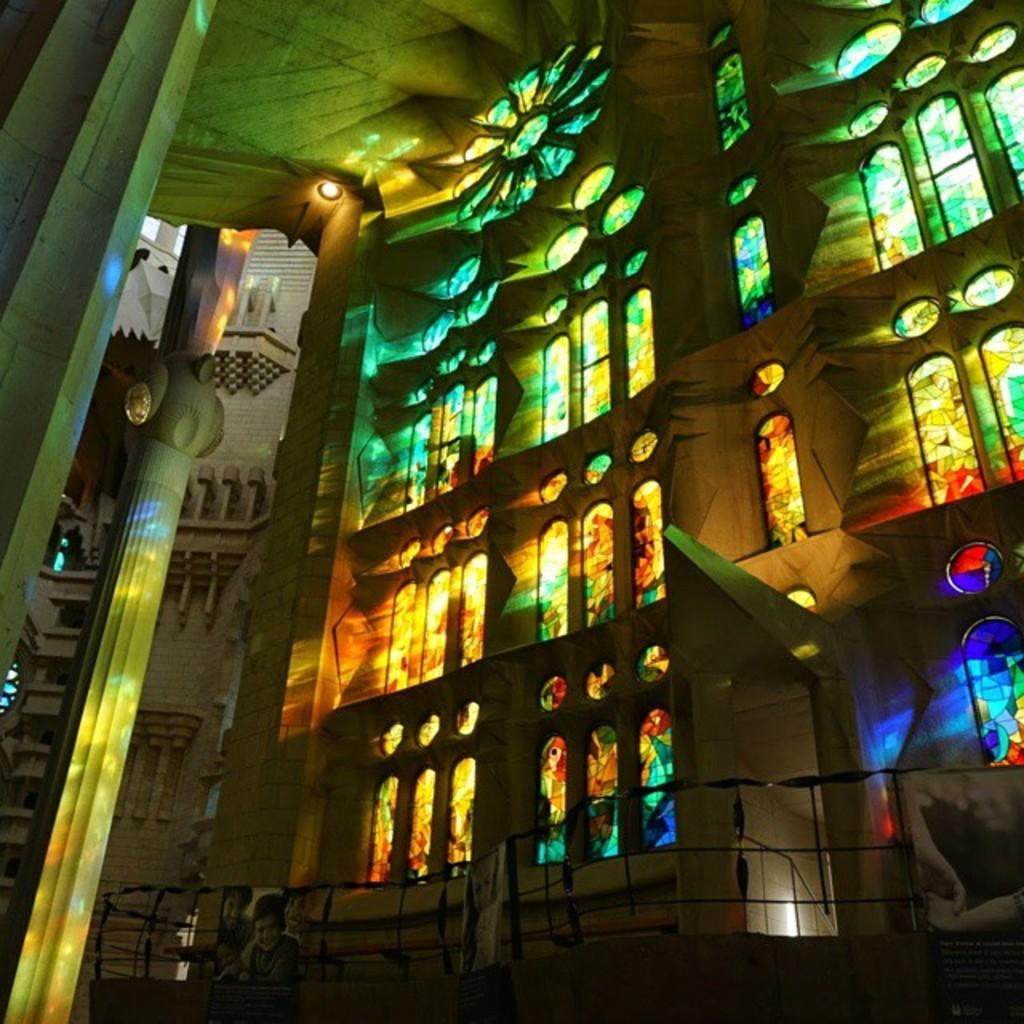What type of structure is visible in the image? There is a building in the image. What feature can be seen on the building? The building has stained glasses. What is located in front of the building? There is a fence in front of the building. Can you describe the pillar on the left side of the image? There is a pillar on the left side of the image. What type of potato is being used to hold the gate open in the image? There is no potato or gate present in the image. 